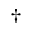Convert formula to latex. <formula><loc_0><loc_0><loc_500><loc_500>\dagger</formula> 